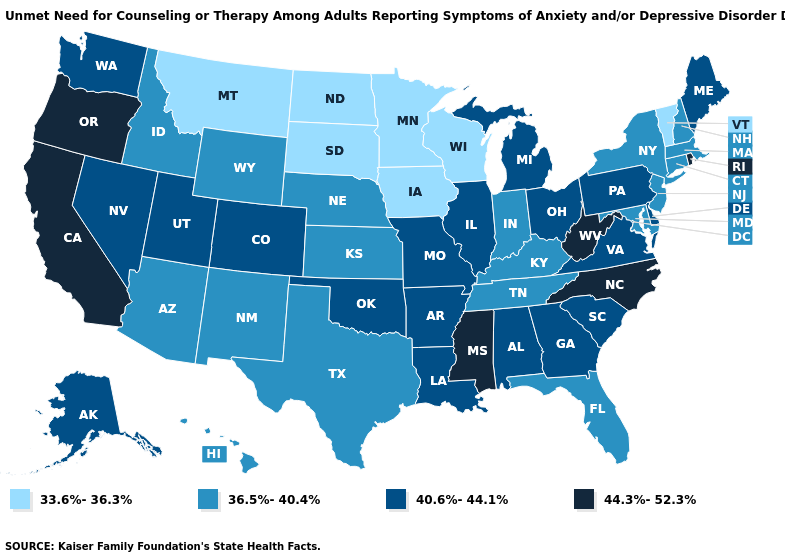Name the states that have a value in the range 36.5%-40.4%?
Give a very brief answer. Arizona, Connecticut, Florida, Hawaii, Idaho, Indiana, Kansas, Kentucky, Maryland, Massachusetts, Nebraska, New Hampshire, New Jersey, New Mexico, New York, Tennessee, Texas, Wyoming. What is the value of Missouri?
Answer briefly. 40.6%-44.1%. Name the states that have a value in the range 33.6%-36.3%?
Write a very short answer. Iowa, Minnesota, Montana, North Dakota, South Dakota, Vermont, Wisconsin. What is the value of North Dakota?
Short answer required. 33.6%-36.3%. Name the states that have a value in the range 44.3%-52.3%?
Quick response, please. California, Mississippi, North Carolina, Oregon, Rhode Island, West Virginia. Which states have the highest value in the USA?
Short answer required. California, Mississippi, North Carolina, Oregon, Rhode Island, West Virginia. What is the value of New York?
Quick response, please. 36.5%-40.4%. Does the map have missing data?
Quick response, please. No. Name the states that have a value in the range 40.6%-44.1%?
Short answer required. Alabama, Alaska, Arkansas, Colorado, Delaware, Georgia, Illinois, Louisiana, Maine, Michigan, Missouri, Nevada, Ohio, Oklahoma, Pennsylvania, South Carolina, Utah, Virginia, Washington. What is the value of Alabama?
Keep it brief. 40.6%-44.1%. Name the states that have a value in the range 44.3%-52.3%?
Short answer required. California, Mississippi, North Carolina, Oregon, Rhode Island, West Virginia. Name the states that have a value in the range 33.6%-36.3%?
Answer briefly. Iowa, Minnesota, Montana, North Dakota, South Dakota, Vermont, Wisconsin. What is the value of Ohio?
Give a very brief answer. 40.6%-44.1%. How many symbols are there in the legend?
Answer briefly. 4. Name the states that have a value in the range 44.3%-52.3%?
Keep it brief. California, Mississippi, North Carolina, Oregon, Rhode Island, West Virginia. 